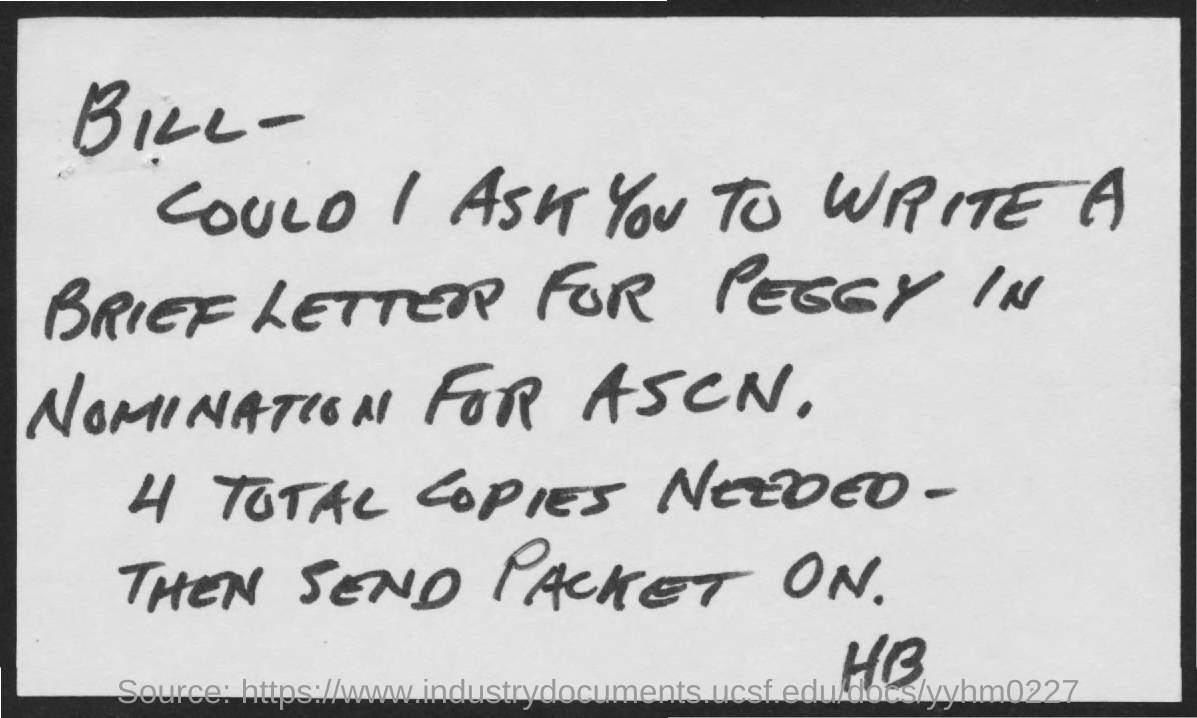To whom, the letter is addressed?
Provide a succinct answer. Bill. How many copies are needed as per the letter?
Give a very brief answer. 4 TOTAL COPIES NEEDED -. 